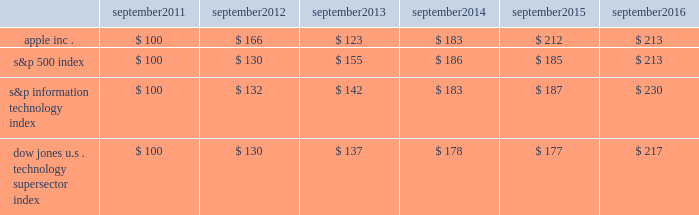Apple inc .
| 2016 form 10-k | 20 company stock performance the following graph shows a comparison of cumulative total shareholder return , calculated on a dividend reinvested basis , for the company , the s&p 500 index , the s&p information technology index and the dow jones u.s .
Technology supersector index for the five years ended september 24 , 2016 .
The graph assumes $ 100 was invested in each of the company 2019s common stock , the s&p 500 index , the s&p information technology index and the dow jones u.s .
Technology supersector index as of the market close on september 23 , 2011 .
Note that historic stock price performance is not necessarily indicative of future stock price performance .
* $ 100 invested on 9/23/11 in stock or index , including reinvestment of dividends .
Data points are the last day of each fiscal year for the company 2019s common stock and september 30th for indexes .
Copyright a9 2016 s&p , a division of mcgraw hill financial .
All rights reserved .
Copyright a9 2016 dow jones & co .
All rights reserved .
September september september september september september .

What was the 1 year return of apple inc . from 2013 to 2014? 
Computations: ((183 - 123) / 123)
Answer: 0.4878. 